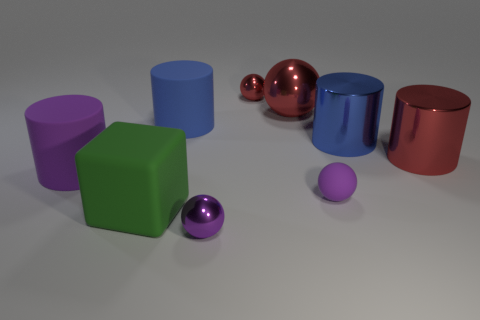The shiny thing that is the same color as the small rubber object is what size?
Offer a terse response. Small. How many other things are there of the same size as the green object?
Give a very brief answer. 5. There is a tiny metal sphere that is in front of the tiny shiny sphere that is to the right of the purple ball on the left side of the tiny purple rubber thing; what color is it?
Keep it short and to the point. Purple. What number of other objects are there of the same shape as the big blue metal thing?
Offer a very short reply. 3. What is the shape of the big rubber object in front of the purple rubber cylinder?
Your answer should be very brief. Cube. There is a metallic object in front of the red cylinder; are there any small purple metallic things in front of it?
Your answer should be very brief. No. There is a thing that is in front of the purple rubber sphere and to the right of the blue rubber cylinder; what is its color?
Make the answer very short. Purple. There is a matte object on the right side of the small ball that is behind the large purple matte cylinder; are there any big rubber objects in front of it?
Offer a terse response. Yes. The other red shiny object that is the same shape as the small red shiny object is what size?
Make the answer very short. Large. Are any tiny gray rubber blocks visible?
Your answer should be very brief. No. 